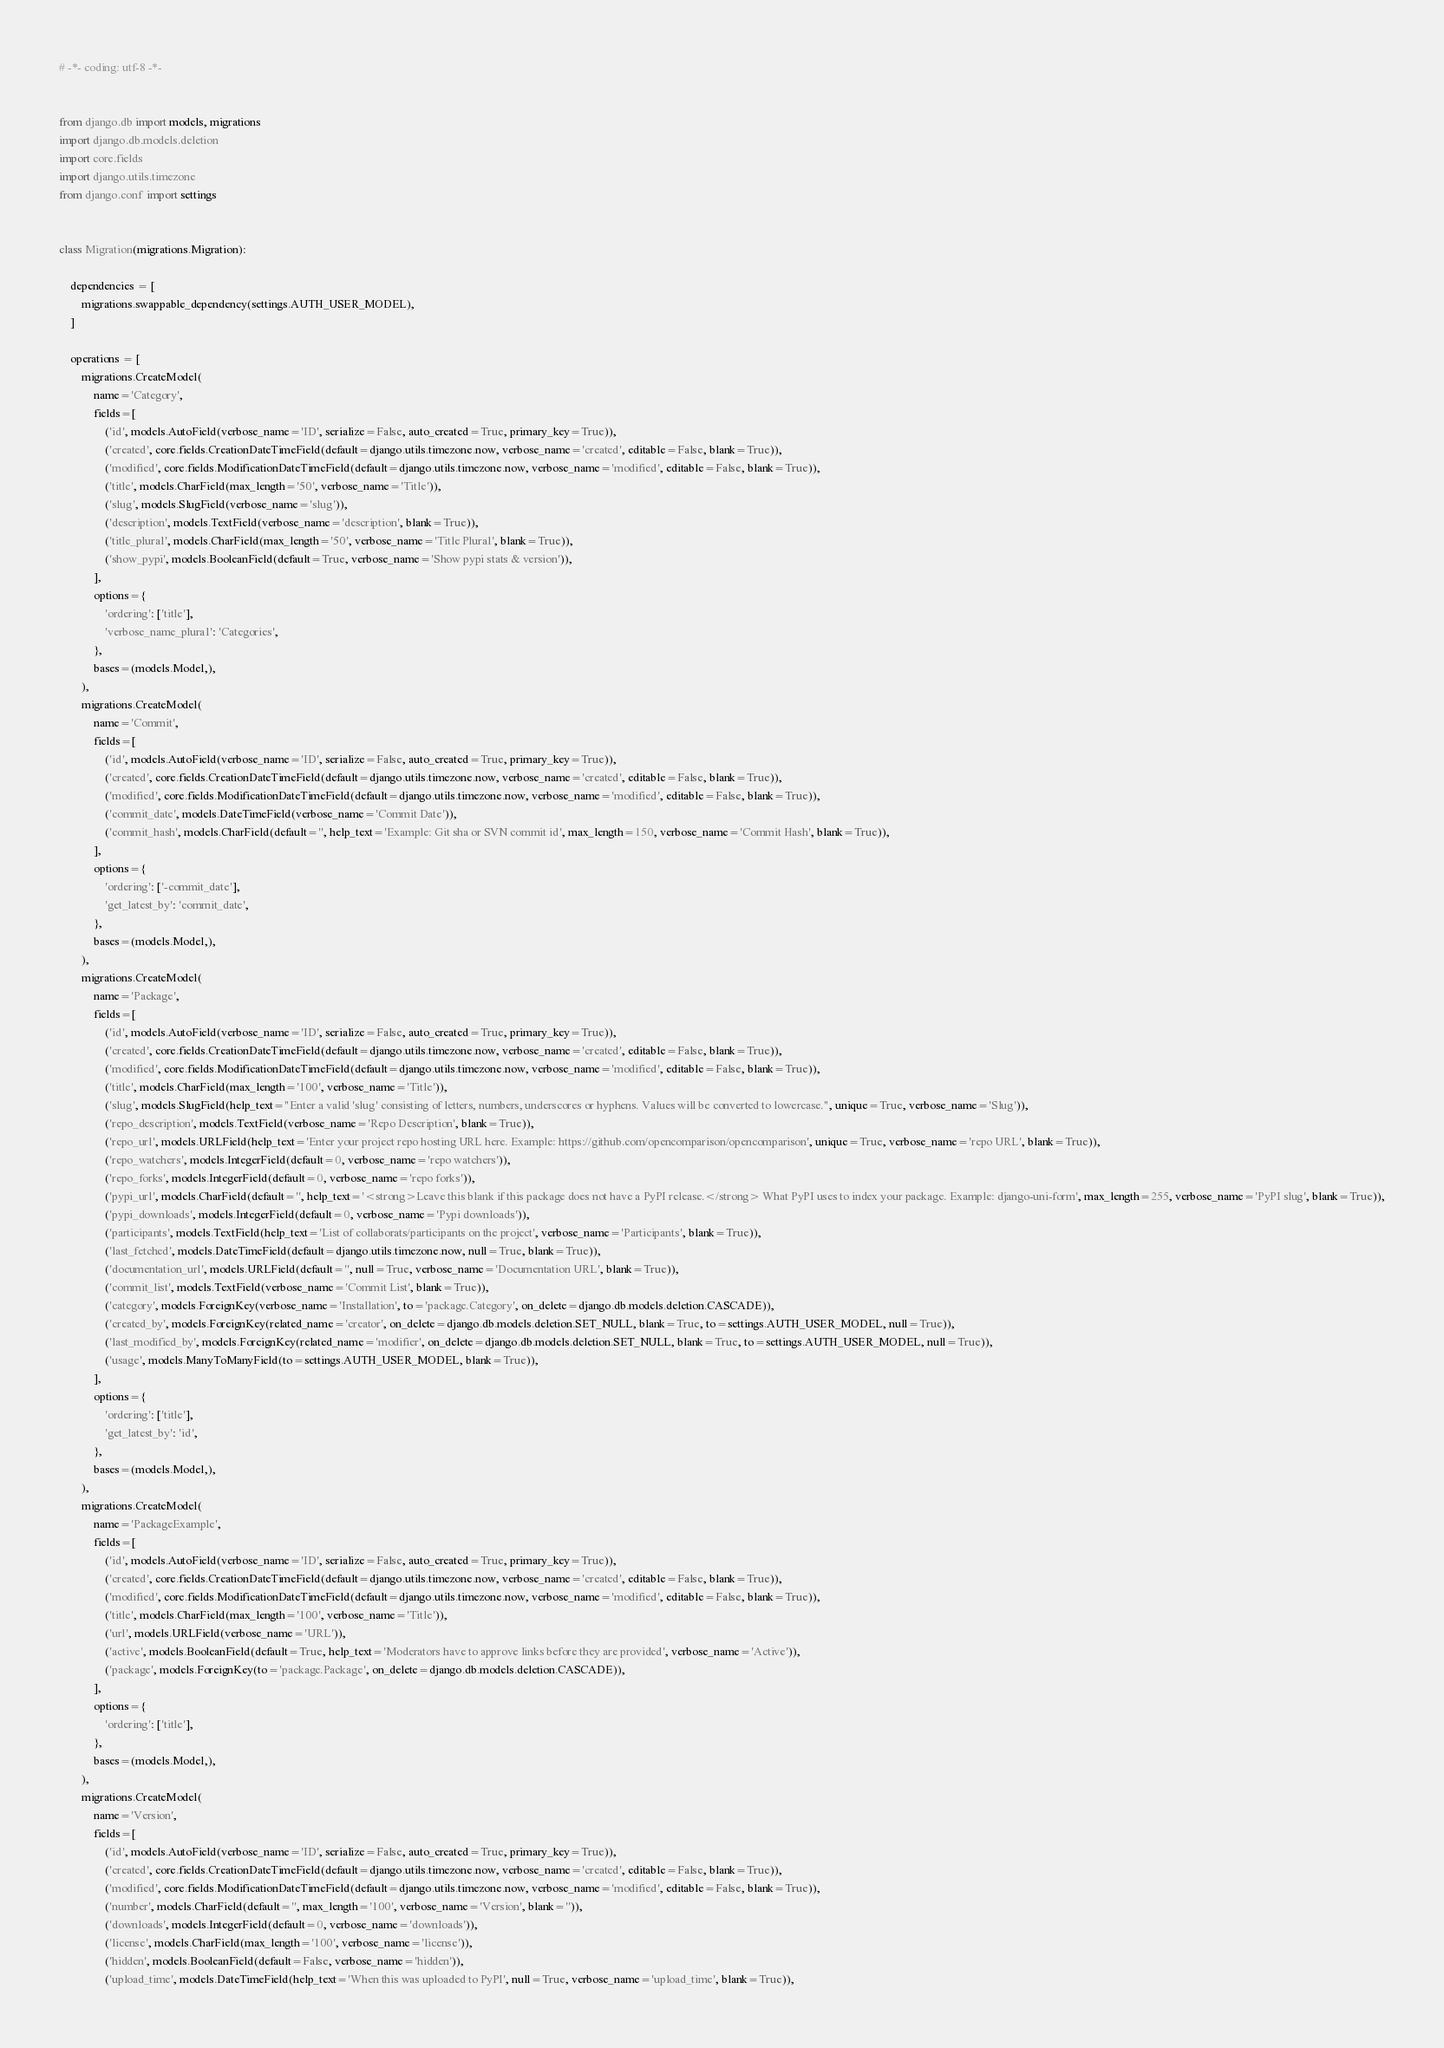<code> <loc_0><loc_0><loc_500><loc_500><_Python_># -*- coding: utf-8 -*-


from django.db import models, migrations
import django.db.models.deletion
import core.fields
import django.utils.timezone
from django.conf import settings


class Migration(migrations.Migration):

    dependencies = [
        migrations.swappable_dependency(settings.AUTH_USER_MODEL),
    ]

    operations = [
        migrations.CreateModel(
            name='Category',
            fields=[
                ('id', models.AutoField(verbose_name='ID', serialize=False, auto_created=True, primary_key=True)),
                ('created', core.fields.CreationDateTimeField(default=django.utils.timezone.now, verbose_name='created', editable=False, blank=True)),
                ('modified', core.fields.ModificationDateTimeField(default=django.utils.timezone.now, verbose_name='modified', editable=False, blank=True)),
                ('title', models.CharField(max_length='50', verbose_name='Title')),
                ('slug', models.SlugField(verbose_name='slug')),
                ('description', models.TextField(verbose_name='description', blank=True)),
                ('title_plural', models.CharField(max_length='50', verbose_name='Title Plural', blank=True)),
                ('show_pypi', models.BooleanField(default=True, verbose_name='Show pypi stats & version')),
            ],
            options={
                'ordering': ['title'],
                'verbose_name_plural': 'Categories',
            },
            bases=(models.Model,),
        ),
        migrations.CreateModel(
            name='Commit',
            fields=[
                ('id', models.AutoField(verbose_name='ID', serialize=False, auto_created=True, primary_key=True)),
                ('created', core.fields.CreationDateTimeField(default=django.utils.timezone.now, verbose_name='created', editable=False, blank=True)),
                ('modified', core.fields.ModificationDateTimeField(default=django.utils.timezone.now, verbose_name='modified', editable=False, blank=True)),
                ('commit_date', models.DateTimeField(verbose_name='Commit Date')),
                ('commit_hash', models.CharField(default='', help_text='Example: Git sha or SVN commit id', max_length=150, verbose_name='Commit Hash', blank=True)),
            ],
            options={
                'ordering': ['-commit_date'],
                'get_latest_by': 'commit_date',
            },
            bases=(models.Model,),
        ),
        migrations.CreateModel(
            name='Package',
            fields=[
                ('id', models.AutoField(verbose_name='ID', serialize=False, auto_created=True, primary_key=True)),
                ('created', core.fields.CreationDateTimeField(default=django.utils.timezone.now, verbose_name='created', editable=False, blank=True)),
                ('modified', core.fields.ModificationDateTimeField(default=django.utils.timezone.now, verbose_name='modified', editable=False, blank=True)),
                ('title', models.CharField(max_length='100', verbose_name='Title')),
                ('slug', models.SlugField(help_text="Enter a valid 'slug' consisting of letters, numbers, underscores or hyphens. Values will be converted to lowercase.", unique=True, verbose_name='Slug')),
                ('repo_description', models.TextField(verbose_name='Repo Description', blank=True)),
                ('repo_url', models.URLField(help_text='Enter your project repo hosting URL here. Example: https://github.com/opencomparison/opencomparison', unique=True, verbose_name='repo URL', blank=True)),
                ('repo_watchers', models.IntegerField(default=0, verbose_name='repo watchers')),
                ('repo_forks', models.IntegerField(default=0, verbose_name='repo forks')),
                ('pypi_url', models.CharField(default='', help_text='<strong>Leave this blank if this package does not have a PyPI release.</strong> What PyPI uses to index your package. Example: django-uni-form', max_length=255, verbose_name='PyPI slug', blank=True)),
                ('pypi_downloads', models.IntegerField(default=0, verbose_name='Pypi downloads')),
                ('participants', models.TextField(help_text='List of collaborats/participants on the project', verbose_name='Participants', blank=True)),
                ('last_fetched', models.DateTimeField(default=django.utils.timezone.now, null=True, blank=True)),
                ('documentation_url', models.URLField(default='', null=True, verbose_name='Documentation URL', blank=True)),
                ('commit_list', models.TextField(verbose_name='Commit List', blank=True)),
                ('category', models.ForeignKey(verbose_name='Installation', to='package.Category', on_delete=django.db.models.deletion.CASCADE)),
                ('created_by', models.ForeignKey(related_name='creator', on_delete=django.db.models.deletion.SET_NULL, blank=True, to=settings.AUTH_USER_MODEL, null=True)),
                ('last_modified_by', models.ForeignKey(related_name='modifier', on_delete=django.db.models.deletion.SET_NULL, blank=True, to=settings.AUTH_USER_MODEL, null=True)),
                ('usage', models.ManyToManyField(to=settings.AUTH_USER_MODEL, blank=True)),
            ],
            options={
                'ordering': ['title'],
                'get_latest_by': 'id',
            },
            bases=(models.Model,),
        ),
        migrations.CreateModel(
            name='PackageExample',
            fields=[
                ('id', models.AutoField(verbose_name='ID', serialize=False, auto_created=True, primary_key=True)),
                ('created', core.fields.CreationDateTimeField(default=django.utils.timezone.now, verbose_name='created', editable=False, blank=True)),
                ('modified', core.fields.ModificationDateTimeField(default=django.utils.timezone.now, verbose_name='modified', editable=False, blank=True)),
                ('title', models.CharField(max_length='100', verbose_name='Title')),
                ('url', models.URLField(verbose_name='URL')),
                ('active', models.BooleanField(default=True, help_text='Moderators have to approve links before they are provided', verbose_name='Active')),
                ('package', models.ForeignKey(to='package.Package', on_delete=django.db.models.deletion.CASCADE)),
            ],
            options={
                'ordering': ['title'],
            },
            bases=(models.Model,),
        ),
        migrations.CreateModel(
            name='Version',
            fields=[
                ('id', models.AutoField(verbose_name='ID', serialize=False, auto_created=True, primary_key=True)),
                ('created', core.fields.CreationDateTimeField(default=django.utils.timezone.now, verbose_name='created', editable=False, blank=True)),
                ('modified', core.fields.ModificationDateTimeField(default=django.utils.timezone.now, verbose_name='modified', editable=False, blank=True)),
                ('number', models.CharField(default='', max_length='100', verbose_name='Version', blank='')),
                ('downloads', models.IntegerField(default=0, verbose_name='downloads')),
                ('license', models.CharField(max_length='100', verbose_name='license')),
                ('hidden', models.BooleanField(default=False, verbose_name='hidden')),
                ('upload_time', models.DateTimeField(help_text='When this was uploaded to PyPI', null=True, verbose_name='upload_time', blank=True)),</code> 